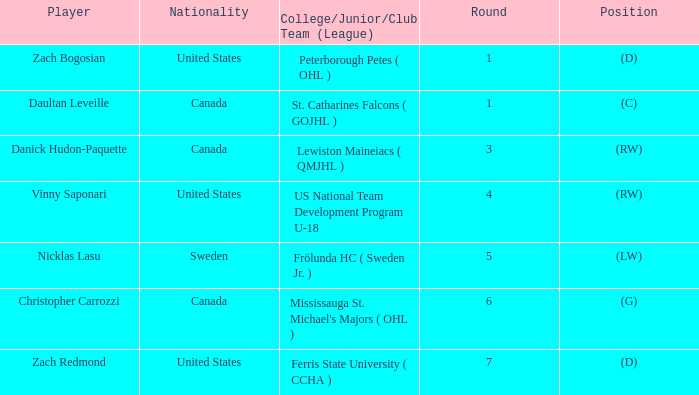What is Daultan Leveille's Position? (C). 